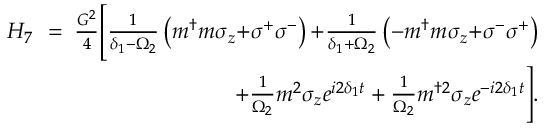Convert formula to latex. <formula><loc_0><loc_0><loc_500><loc_500>\begin{array} { r l r } { H _ { 7 } \, } & { = } & { \, \frac { G ^ { 2 } } { 4 } \left [ \frac { 1 } { \delta _ { 1 } { - } \Omega _ { 2 } } \left ( m ^ { \dagger } m \sigma _ { z } { + } \sigma ^ { + } \sigma ^ { - } \right ) { + } \frac { 1 } { \delta _ { 1 } { + } \Omega _ { 2 } } \left ( - m ^ { \dagger } m \sigma _ { z } { + } \sigma ^ { - } \sigma ^ { + } \right ) } \\ & { \, + \frac { 1 } { \Omega _ { 2 } } m ^ { 2 } \sigma _ { z } e ^ { i 2 \delta _ { 1 } t } + \frac { 1 } { \Omega _ { 2 } } m ^ { \dagger 2 } \sigma _ { z } e ^ { - i 2 \delta _ { 1 } t } \right ] . } \end{array}</formula> 